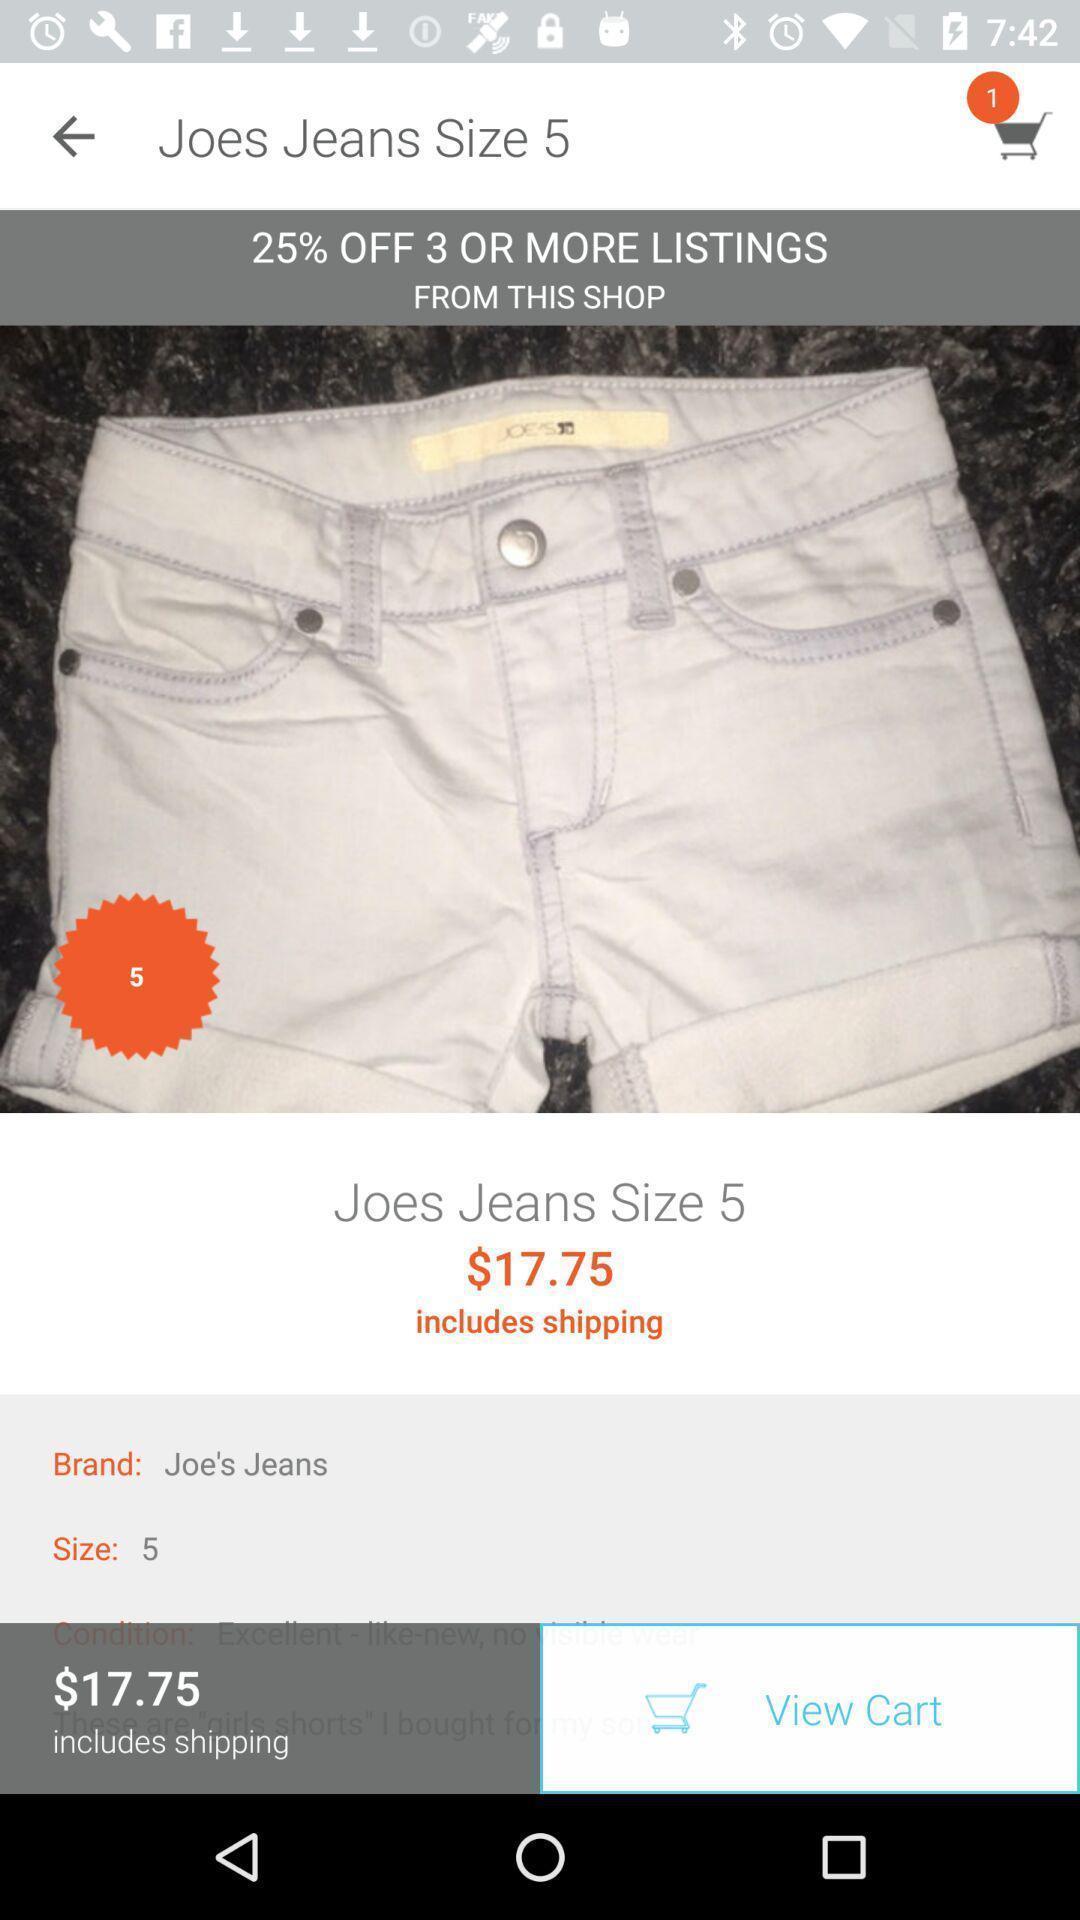Describe the key features of this screenshot. Screen page displaying a product details in shopping application. 